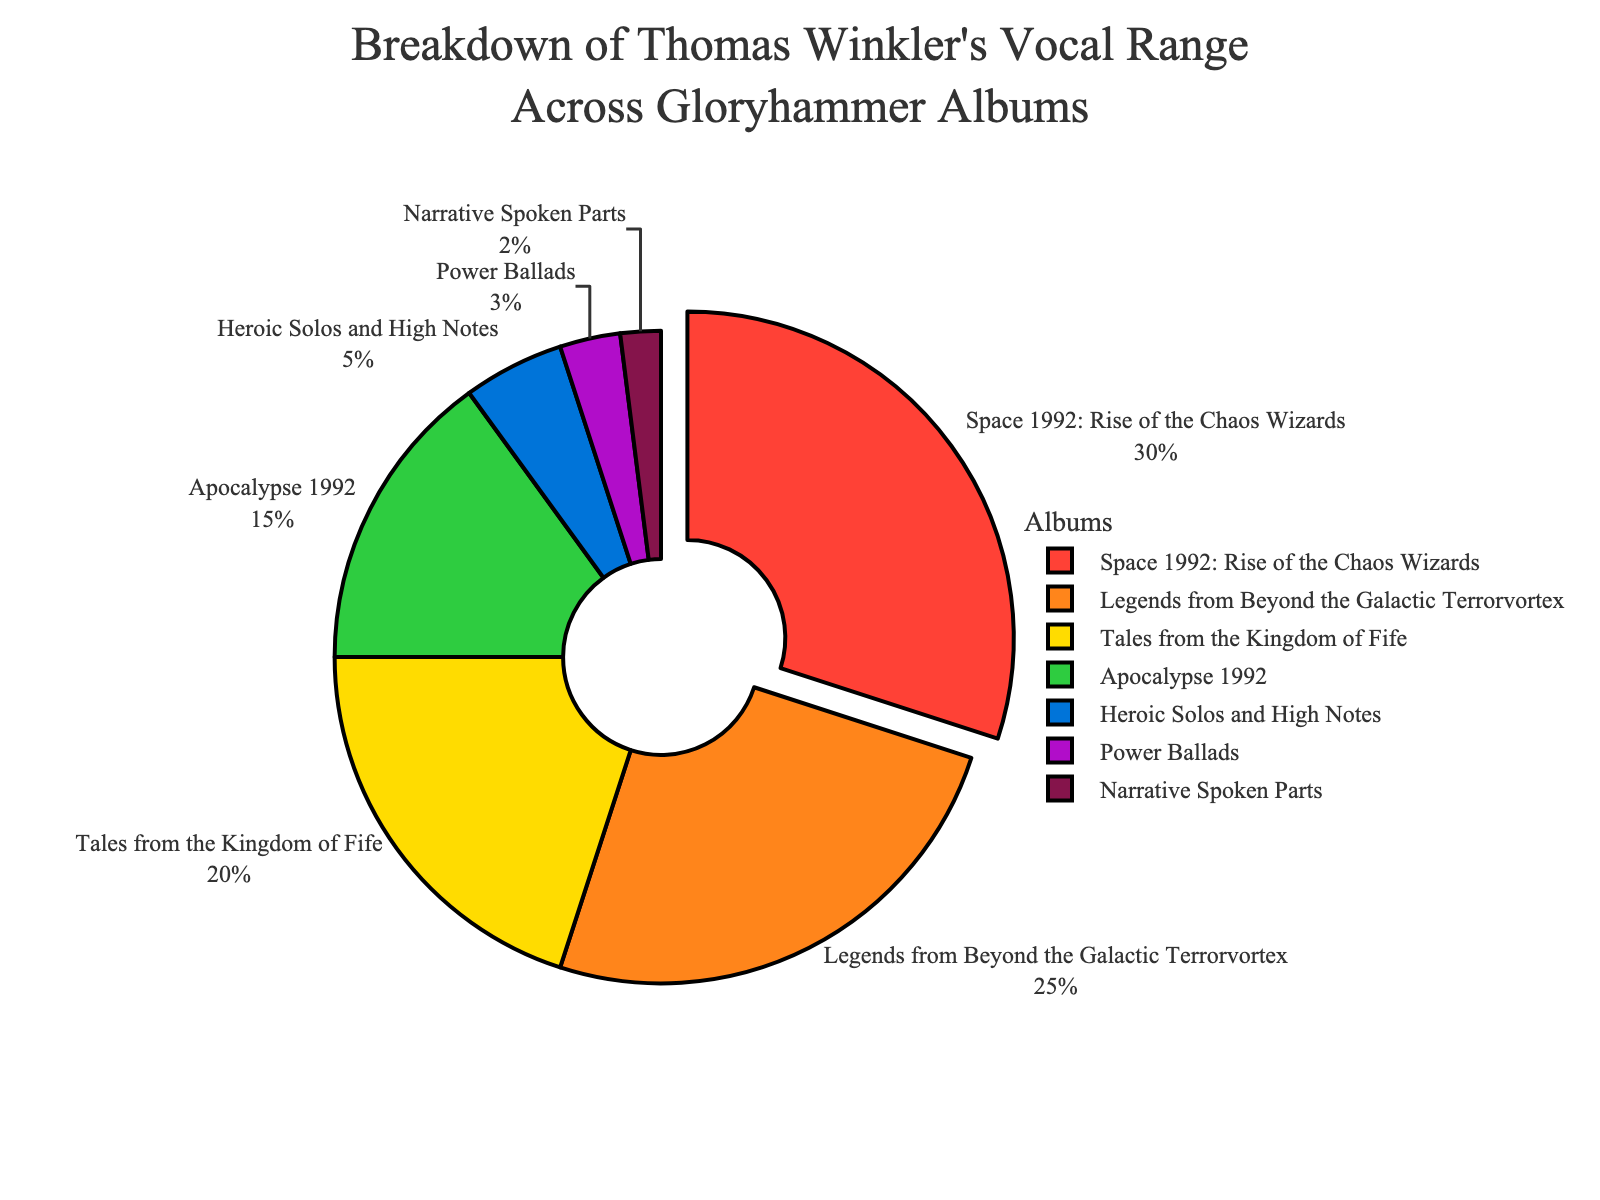What album has the highest percentage of vocal range usage? The pie chart shows each album's percentage of Thomas Winkler's vocal range. The largest segment corresponds to "Space 1992: Rise of the Chaos Wizards," with 30%.
Answer: Space 1992: Rise of the Chaos Wizards What is the sum of the vocal range usage for "Space 1992: Rise of the Chaos Wizards" and "Legends from Beyond the Galactic Terrorvortex"? Add the percentages for "Space 1992: Rise of the Chaos Wizards" (30%) and "Legends from Beyond the Galactic Terrorvortex" (25%). 30% + 25% = 55%.
Answer: 55% Which album uses less of the vocal range: "Tales from the Kingdom of Fife" or "Apocalypse 1992"? Compare the segments for "Tales from the Kingdom of Fife" (20%) and "Apocalypse 1992" (15%). "Apocalypse 1992" has a lower percentage.
Answer: Apocalypse 1992 What is the difference in the percentage of vocal range usage between "Heroic Solos and High Notes" and "Power Ballads"? Subtract the percentage for "Power Ballads" (3%) from "Heroic Solos and High Notes" (5%). 5% - 3% = 2%.
Answer: 2% How many albums have a vocal range usage of 10% or less? Identify the albums with percentages 10% or less: "Heroic Solos and High Notes" (5%), "Power Ballads" (3%), and "Narrative Spoken Parts" (2%). There are 3 such albums.
Answer: 3 Which album has the smallest percentage of Thomas Winkler's vocal range usage? Identify the smallest segment in the pie chart, which is "Narrative Spoken Parts," with 2%.
Answer: Narrative Spoken Parts Does the combined vocal range usage for "Heroic Solos and High Notes" and "Power Ballads" exceed that of "Tales from the Kingdom of Fife"? Sum the percentages for "Heroic Solos and High Notes" (5%) and "Power Ballads" (3%), then compare to "Tales from the Kingdom of Fife" (20%). 5% + 3% = 8%, which is less than 20%.
Answer: No What percentage of the total vocal range usage is allocated to "Space 1992: Rise of the Chaos Wizards" and "Tales from the Kingdom of Fife" combined? Sum the percentages for "Space 1992: Rise of the Chaos Wizards" (30%) and "Tales from the Kingdom of Fife" (20%). 30% + 20% = 50%.
Answer: 50% What is the median percentage of vocal range usage across all albums? List the percentages: 30, 25, 20, 15, 5, 3, 2. The median is the middle value, which is 15% (Apocalypse 1992).
Answer: 15% Which albums use more than 20% of Thomas Winkler's vocal range? Identify albums with percentages greater than 20%: "Space 1992: Rise of the Chaos Wizards" (30%) and "Legends from Beyond the Galactic Terrorvortex" (25%).
Answer: Space 1992: Rise of the Chaos Wizards, Legends from Beyond the Galactic Terrorvortex 